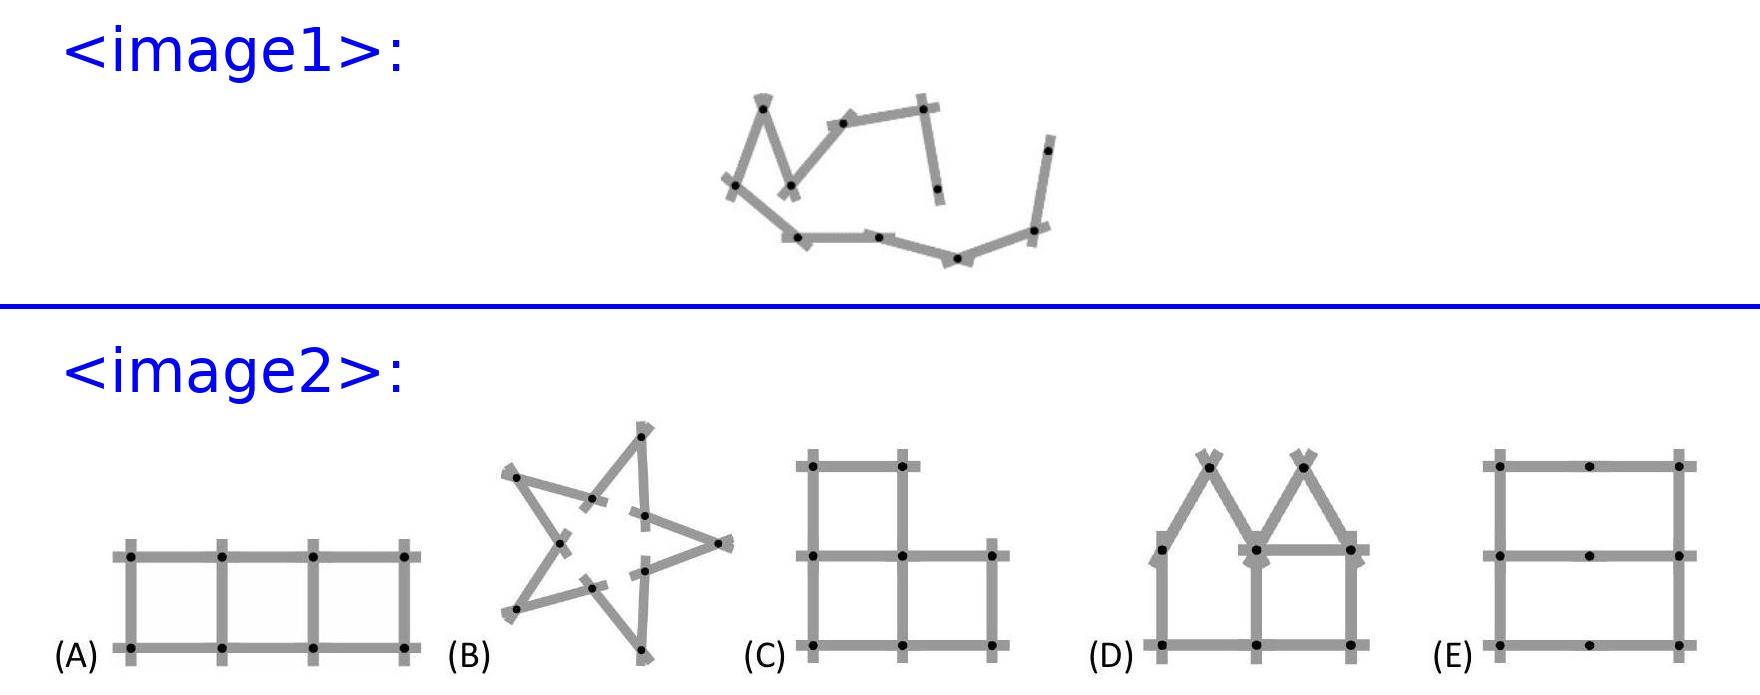<image2> How can figure B be constructed using a folding yardstick with 10 pieces? Figure B can be constructed by fully extending the yardstick to form two parallel lines. Then, using 4 equal pieces to connect the ends at right angles forms the complete shape. This utilization of the yardstick takes advantage of its rigid and equal segmentation. 